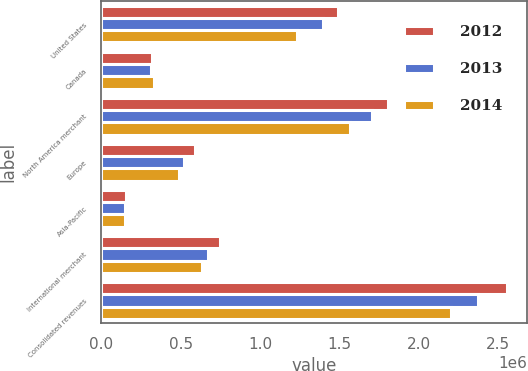Convert chart. <chart><loc_0><loc_0><loc_500><loc_500><stacked_bar_chart><ecel><fcel>United States<fcel>Canada<fcel>North America merchant<fcel>Europe<fcel>Asia-Pacific<fcel>International merchant<fcel>Consolidated revenues<nl><fcel>2012<fcel>1.48866e+06<fcel>320333<fcel>1.80899e+06<fcel>587463<fcel>157781<fcel>745244<fcel>2.55424e+06<nl><fcel>2013<fcel>1.39468e+06<fcel>311000<fcel>1.70568e+06<fcel>522593<fcel>147655<fcel>670248<fcel>2.37592e+06<nl><fcel>2014<fcel>1.23482e+06<fcel>332434<fcel>1.56725e+06<fcel>489300<fcel>147295<fcel>636595<fcel>2.20385e+06<nl></chart> 